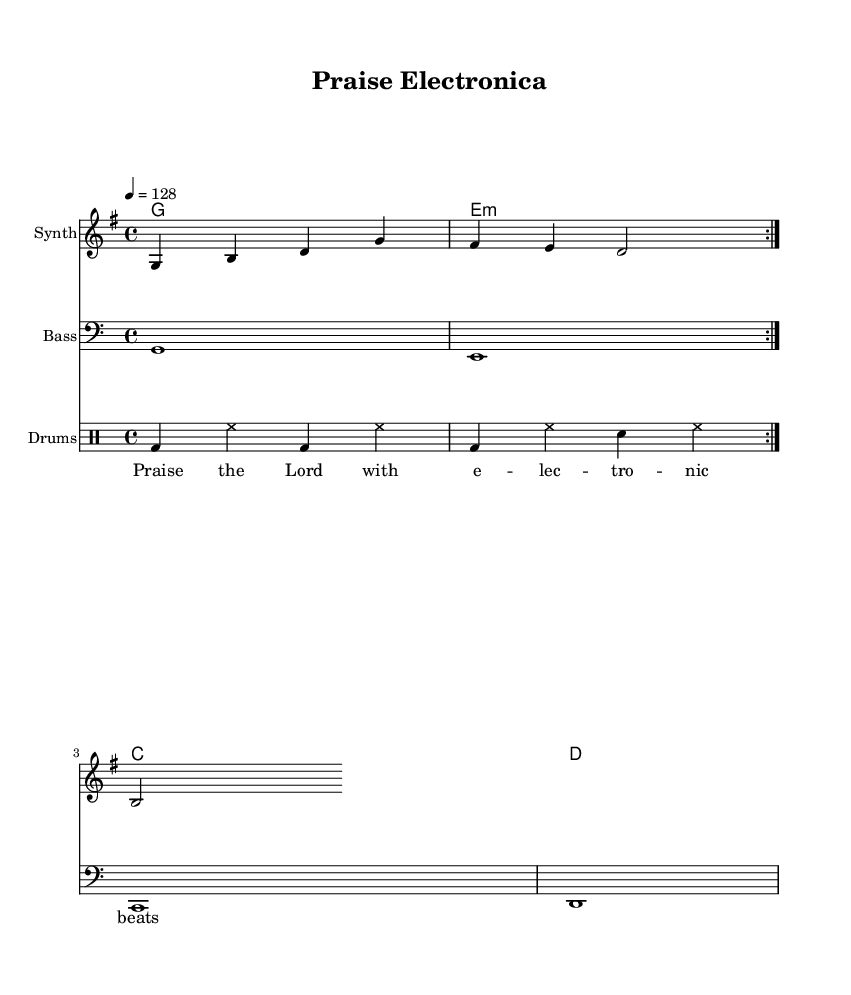What is the key signature of this music? The key signature is G major, which has one sharp (F#). This can be confirmed by looking at the key signature indicated at the beginning of the piece.
Answer: G major What is the time signature of this music? The time signature is 4/4, which means there are four beats per measure. This is stated at the beginning of the score and sets the rhythmic structure for the piece.
Answer: 4/4 What is the tempo marking for this music? The tempo marking is 128 beats per minute, indicated by the tempo instruction "4 = 128." This tells musicians how fast to play the piece.
Answer: 128 How many measures are in the melody section? The melody section consists of four measures, which can be counted by identifying the vertical bar lines separating the measures in the score.
Answer: 4 What is the primary instrument used for the melody? The primary instrument used for the melody is indicated as "Synth" in the instrument name for the staff where the melody is written. This denotes the electronic sound that is characteristic of the genre.
Answer: Synth Which chords are used in the harmonies? The chords used are G, E minor, C, and D, as specified in the chord names section, which outlines the harmonic structure supporting the melody.
Answer: G, E minor, C, D What do the lyrics in the verse express? The lyrics express a theme of praising the Lord using electronic beats, as indicated by the words in the lyric section that reflect a joyful, worshipful sentiment fitting for a dance style.
Answer: Praise the Lord with electronic beats 